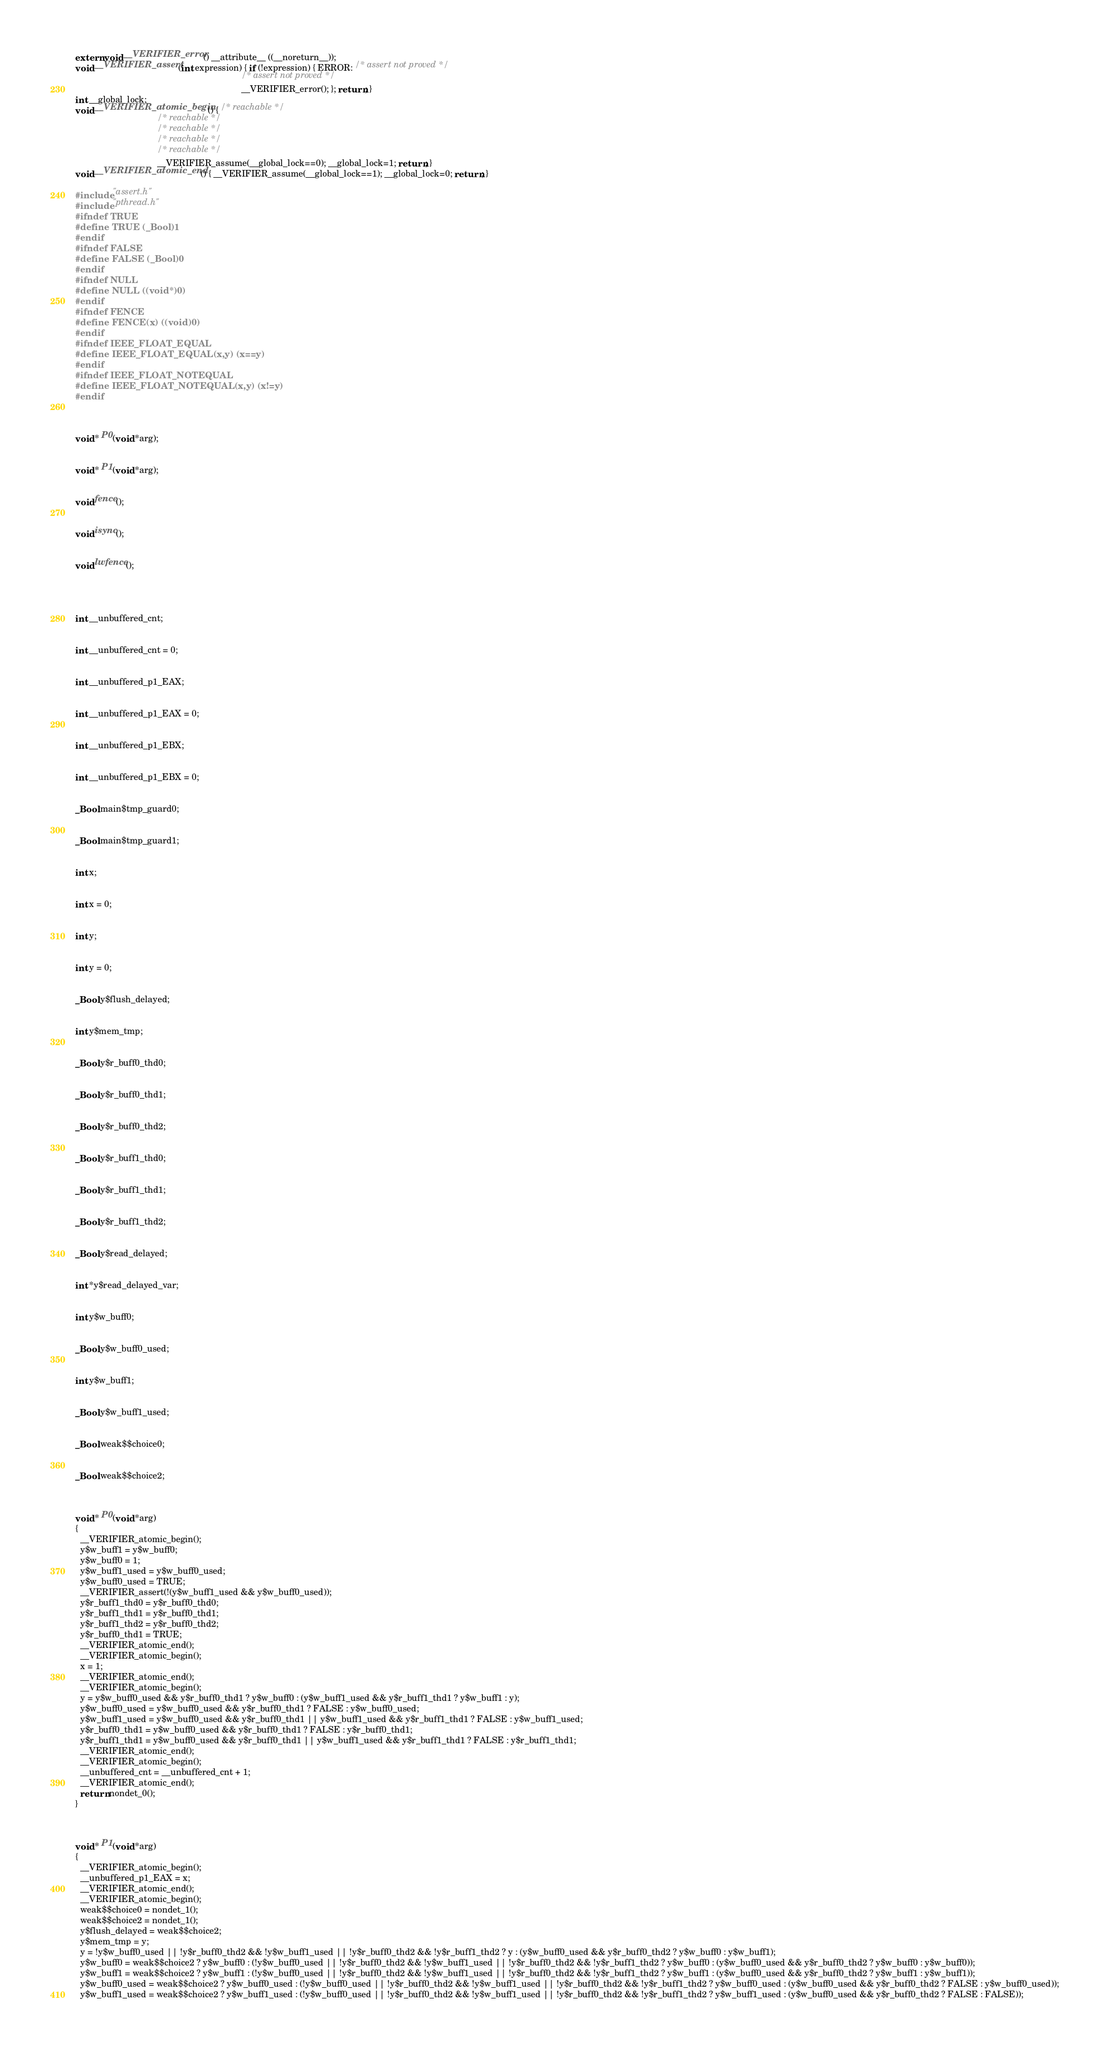Convert code to text. <code><loc_0><loc_0><loc_500><loc_500><_C_>extern void __VERIFIER_error() __attribute__ ((__noreturn__));
void __VERIFIER_assert(int expression) { if (!expression) { ERROR: /* assert not proved */
                                                                   /* assert not proved */
                                                                   __VERIFIER_error(); }; return; }
int __global_lock;
void __VERIFIER_atomic_begin() { /* reachable */
                                 /* reachable */
                                 /* reachable */
                                 /* reachable */
                                 /* reachable */
                                 __VERIFIER_assume(__global_lock==0); __global_lock=1; return; }
void __VERIFIER_atomic_end() { __VERIFIER_assume(__global_lock==1); __global_lock=0; return; }

#include "assert.h"
#include "pthread.h"
#ifndef TRUE
#define TRUE (_Bool)1
#endif
#ifndef FALSE
#define FALSE (_Bool)0
#endif
#ifndef NULL
#define NULL ((void*)0)
#endif
#ifndef FENCE
#define FENCE(x) ((void)0)
#endif
#ifndef IEEE_FLOAT_EQUAL
#define IEEE_FLOAT_EQUAL(x,y) (x==y)
#endif
#ifndef IEEE_FLOAT_NOTEQUAL
#define IEEE_FLOAT_NOTEQUAL(x,y) (x!=y)
#endif



void * P0(void *arg);


void * P1(void *arg);


void fence();


void isync();


void lwfence();




int __unbuffered_cnt;


int __unbuffered_cnt = 0;


int __unbuffered_p1_EAX;


int __unbuffered_p1_EAX = 0;


int __unbuffered_p1_EBX;


int __unbuffered_p1_EBX = 0;


_Bool main$tmp_guard0;


_Bool main$tmp_guard1;


int x;


int x = 0;


int y;


int y = 0;


_Bool y$flush_delayed;


int y$mem_tmp;


_Bool y$r_buff0_thd0;


_Bool y$r_buff0_thd1;


_Bool y$r_buff0_thd2;


_Bool y$r_buff1_thd0;


_Bool y$r_buff1_thd1;


_Bool y$r_buff1_thd2;


_Bool y$read_delayed;


int *y$read_delayed_var;


int y$w_buff0;


_Bool y$w_buff0_used;


int y$w_buff1;


_Bool y$w_buff1_used;


_Bool weak$$choice0;


_Bool weak$$choice2;



void * P0(void *arg)
{
  __VERIFIER_atomic_begin();
  y$w_buff1 = y$w_buff0;
  y$w_buff0 = 1;
  y$w_buff1_used = y$w_buff0_used;
  y$w_buff0_used = TRUE;
  __VERIFIER_assert(!(y$w_buff1_used && y$w_buff0_used));
  y$r_buff1_thd0 = y$r_buff0_thd0;
  y$r_buff1_thd1 = y$r_buff0_thd1;
  y$r_buff1_thd2 = y$r_buff0_thd2;
  y$r_buff0_thd1 = TRUE;
  __VERIFIER_atomic_end();
  __VERIFIER_atomic_begin();
  x = 1;
  __VERIFIER_atomic_end();
  __VERIFIER_atomic_begin();
  y = y$w_buff0_used && y$r_buff0_thd1 ? y$w_buff0 : (y$w_buff1_used && y$r_buff1_thd1 ? y$w_buff1 : y);
  y$w_buff0_used = y$w_buff0_used && y$r_buff0_thd1 ? FALSE : y$w_buff0_used;
  y$w_buff1_used = y$w_buff0_used && y$r_buff0_thd1 || y$w_buff1_used && y$r_buff1_thd1 ? FALSE : y$w_buff1_used;
  y$r_buff0_thd1 = y$w_buff0_used && y$r_buff0_thd1 ? FALSE : y$r_buff0_thd1;
  y$r_buff1_thd1 = y$w_buff0_used && y$r_buff0_thd1 || y$w_buff1_used && y$r_buff1_thd1 ? FALSE : y$r_buff1_thd1;
  __VERIFIER_atomic_end();
  __VERIFIER_atomic_begin();
  __unbuffered_cnt = __unbuffered_cnt + 1;
  __VERIFIER_atomic_end();
  return nondet_0();
}



void * P1(void *arg)
{
  __VERIFIER_atomic_begin();
  __unbuffered_p1_EAX = x;
  __VERIFIER_atomic_end();
  __VERIFIER_atomic_begin();
  weak$$choice0 = nondet_1();
  weak$$choice2 = nondet_1();
  y$flush_delayed = weak$$choice2;
  y$mem_tmp = y;
  y = !y$w_buff0_used || !y$r_buff0_thd2 && !y$w_buff1_used || !y$r_buff0_thd2 && !y$r_buff1_thd2 ? y : (y$w_buff0_used && y$r_buff0_thd2 ? y$w_buff0 : y$w_buff1);
  y$w_buff0 = weak$$choice2 ? y$w_buff0 : (!y$w_buff0_used || !y$r_buff0_thd2 && !y$w_buff1_used || !y$r_buff0_thd2 && !y$r_buff1_thd2 ? y$w_buff0 : (y$w_buff0_used && y$r_buff0_thd2 ? y$w_buff0 : y$w_buff0));
  y$w_buff1 = weak$$choice2 ? y$w_buff1 : (!y$w_buff0_used || !y$r_buff0_thd2 && !y$w_buff1_used || !y$r_buff0_thd2 && !y$r_buff1_thd2 ? y$w_buff1 : (y$w_buff0_used && y$r_buff0_thd2 ? y$w_buff1 : y$w_buff1));
  y$w_buff0_used = weak$$choice2 ? y$w_buff0_used : (!y$w_buff0_used || !y$r_buff0_thd2 && !y$w_buff1_used || !y$r_buff0_thd2 && !y$r_buff1_thd2 ? y$w_buff0_used : (y$w_buff0_used && y$r_buff0_thd2 ? FALSE : y$w_buff0_used));
  y$w_buff1_used = weak$$choice2 ? y$w_buff1_used : (!y$w_buff0_used || !y$r_buff0_thd2 && !y$w_buff1_used || !y$r_buff0_thd2 && !y$r_buff1_thd2 ? y$w_buff1_used : (y$w_buff0_used && y$r_buff0_thd2 ? FALSE : FALSE));</code> 